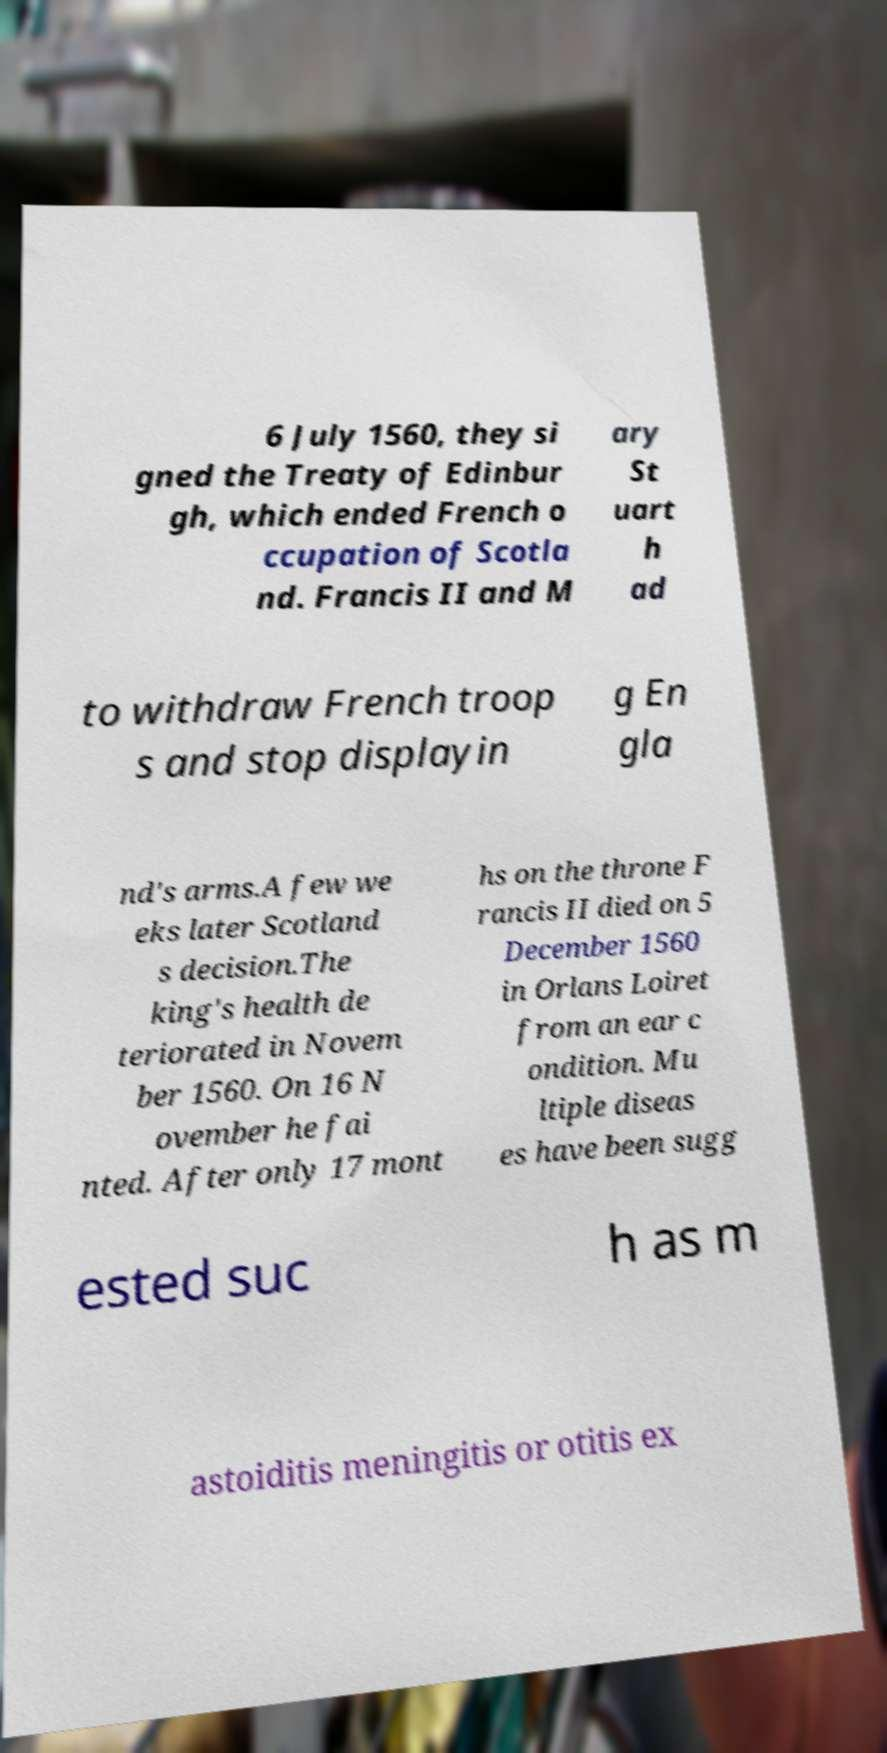Could you extract and type out the text from this image? 6 July 1560, they si gned the Treaty of Edinbur gh, which ended French o ccupation of Scotla nd. Francis II and M ary St uart h ad to withdraw French troop s and stop displayin g En gla nd's arms.A few we eks later Scotland s decision.The king's health de teriorated in Novem ber 1560. On 16 N ovember he fai nted. After only 17 mont hs on the throne F rancis II died on 5 December 1560 in Orlans Loiret from an ear c ondition. Mu ltiple diseas es have been sugg ested suc h as m astoiditis meningitis or otitis ex 